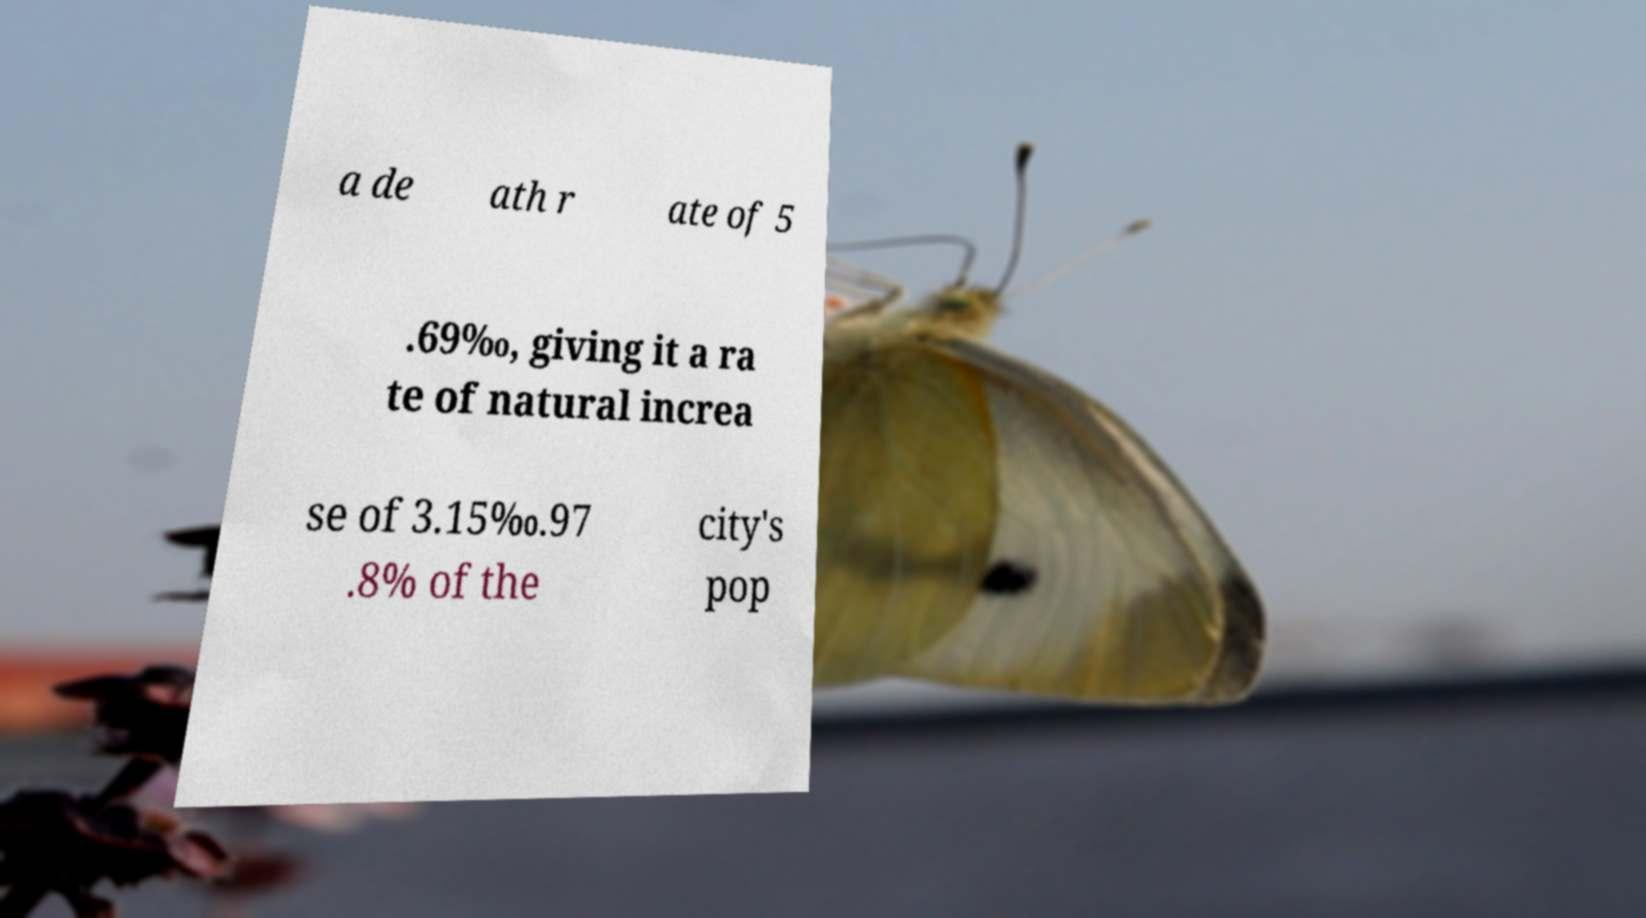What messages or text are displayed in this image? I need them in a readable, typed format. a de ath r ate of 5 .69‰, giving it a ra te of natural increa se of 3.15‰.97 .8% of the city's pop 